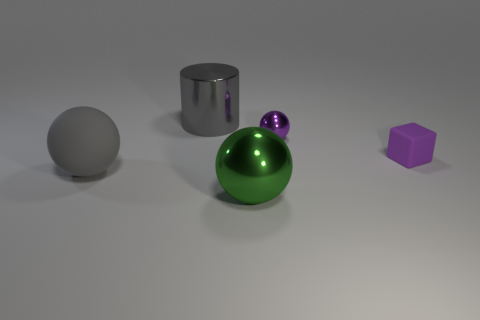Subtract all red cylinders. Subtract all cyan cubes. How many cylinders are left? 1 Add 4 big cyan cylinders. How many objects exist? 9 Subtract all spheres. How many objects are left? 2 Subtract all blue rubber cubes. Subtract all tiny matte things. How many objects are left? 4 Add 3 big green metal spheres. How many big green metal spheres are left? 4 Add 3 large gray shiny cylinders. How many large gray shiny cylinders exist? 4 Subtract 0 cyan blocks. How many objects are left? 5 